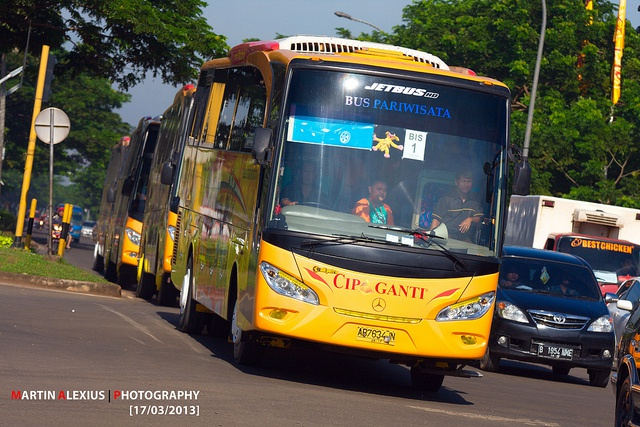Describe the objects in this image and their specific colors. I can see bus in black, gray, navy, and gold tones, car in black, navy, gray, and darkgray tones, truck in black, ivory, gray, and navy tones, bus in black, olive, and gray tones, and bus in black and gray tones in this image. 